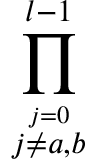<formula> <loc_0><loc_0><loc_500><loc_500>\prod _ { \stackrel { j = 0 } { j \neq a , b } } ^ { l - 1 }</formula> 